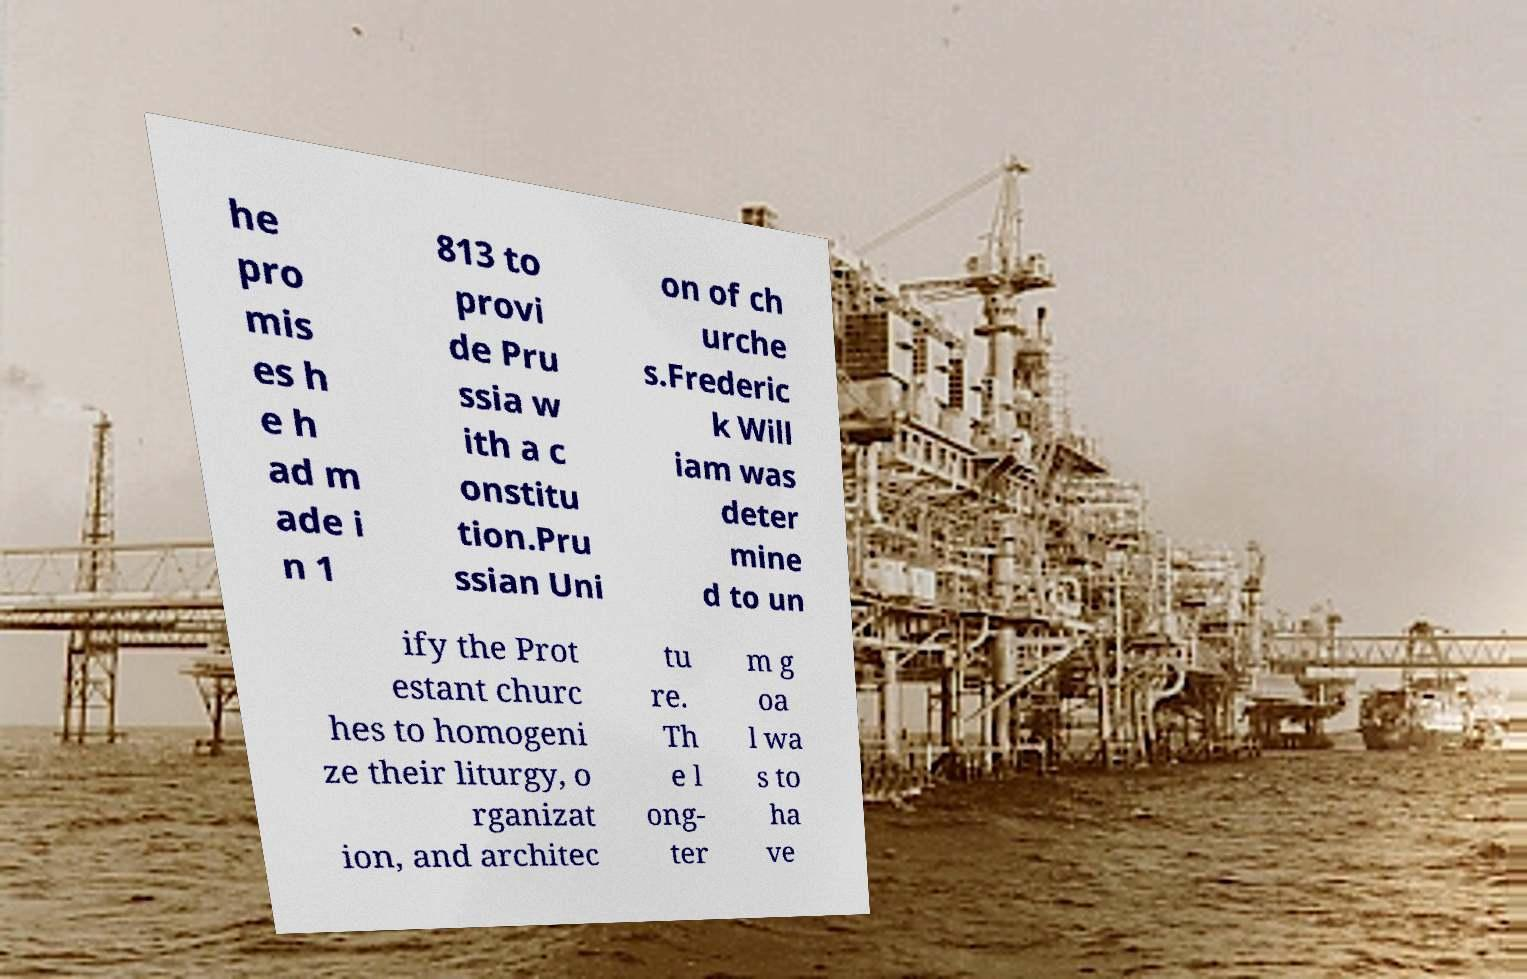Could you assist in decoding the text presented in this image and type it out clearly? he pro mis es h e h ad m ade i n 1 813 to provi de Pru ssia w ith a c onstitu tion.Pru ssian Uni on of ch urche s.Frederic k Will iam was deter mine d to un ify the Prot estant churc hes to homogeni ze their liturgy, o rganizat ion, and architec tu re. Th e l ong- ter m g oa l wa s to ha ve 